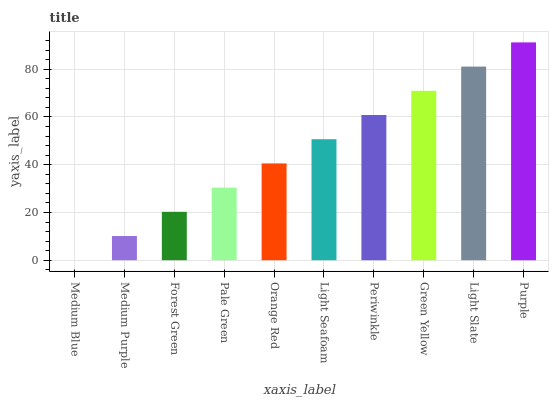Is Medium Blue the minimum?
Answer yes or no. Yes. Is Purple the maximum?
Answer yes or no. Yes. Is Medium Purple the minimum?
Answer yes or no. No. Is Medium Purple the maximum?
Answer yes or no. No. Is Medium Purple greater than Medium Blue?
Answer yes or no. Yes. Is Medium Blue less than Medium Purple?
Answer yes or no. Yes. Is Medium Blue greater than Medium Purple?
Answer yes or no. No. Is Medium Purple less than Medium Blue?
Answer yes or no. No. Is Light Seafoam the high median?
Answer yes or no. Yes. Is Orange Red the low median?
Answer yes or no. Yes. Is Medium Blue the high median?
Answer yes or no. No. Is Purple the low median?
Answer yes or no. No. 